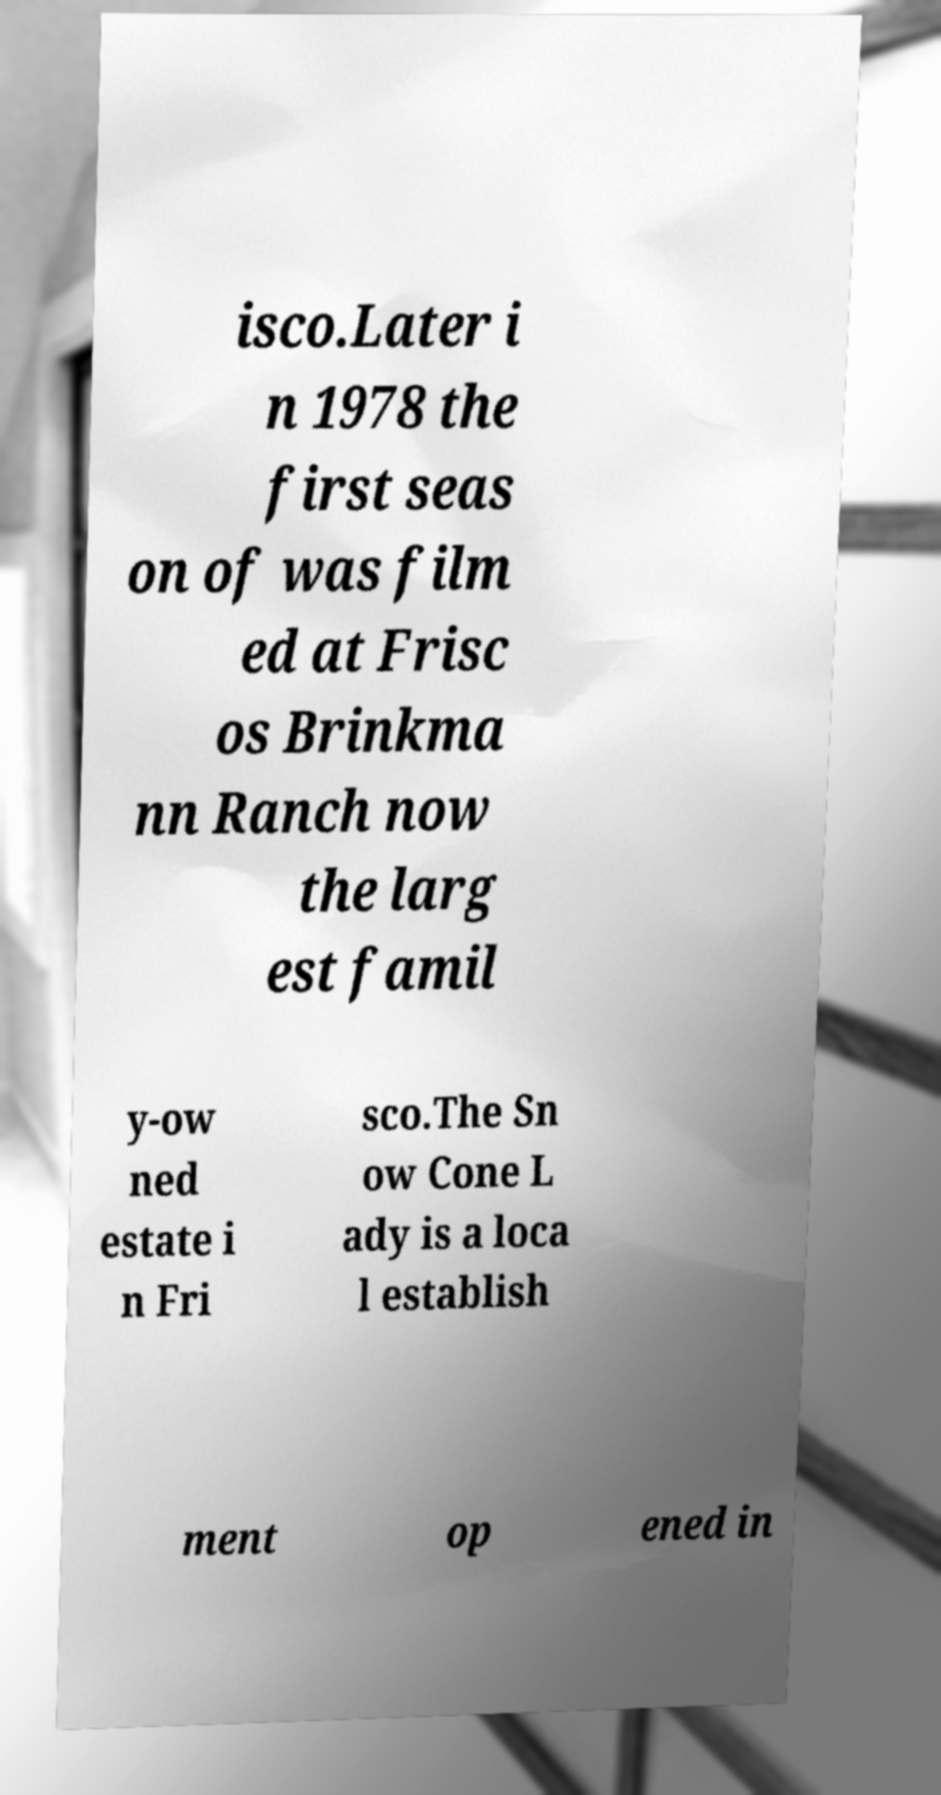Please identify and transcribe the text found in this image. isco.Later i n 1978 the first seas on of was film ed at Frisc os Brinkma nn Ranch now the larg est famil y-ow ned estate i n Fri sco.The Sn ow Cone L ady is a loca l establish ment op ened in 